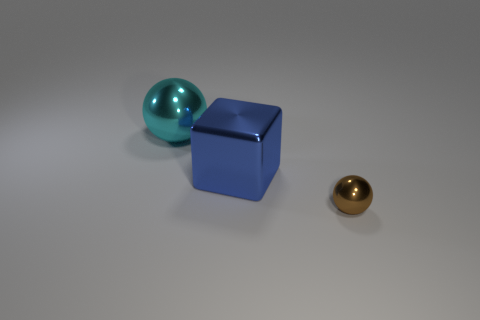The cyan thing that is made of the same material as the tiny sphere is what shape?
Keep it short and to the point. Sphere. Are there any other things of the same color as the large metallic block?
Provide a succinct answer. No. How many shiny things are to the left of the small brown metallic sphere that is on the right side of the sphere behind the small shiny sphere?
Your answer should be very brief. 2. How many red things are cubes or tiny balls?
Your answer should be very brief. 0. Do the brown object and the sphere that is behind the small brown sphere have the same size?
Give a very brief answer. No. There is another tiny thing that is the same shape as the cyan metal thing; what is it made of?
Provide a succinct answer. Metal. What number of other objects are the same size as the brown metal thing?
Keep it short and to the point. 0. What is the shape of the big object on the left side of the large metallic object right of the object that is behind the blue metallic block?
Your answer should be compact. Sphere. There is a metallic thing that is behind the small brown object and right of the big cyan metallic ball; what shape is it?
Your response must be concise. Cube. How many things are either cyan things or metal things that are behind the tiny sphere?
Offer a terse response. 2. 